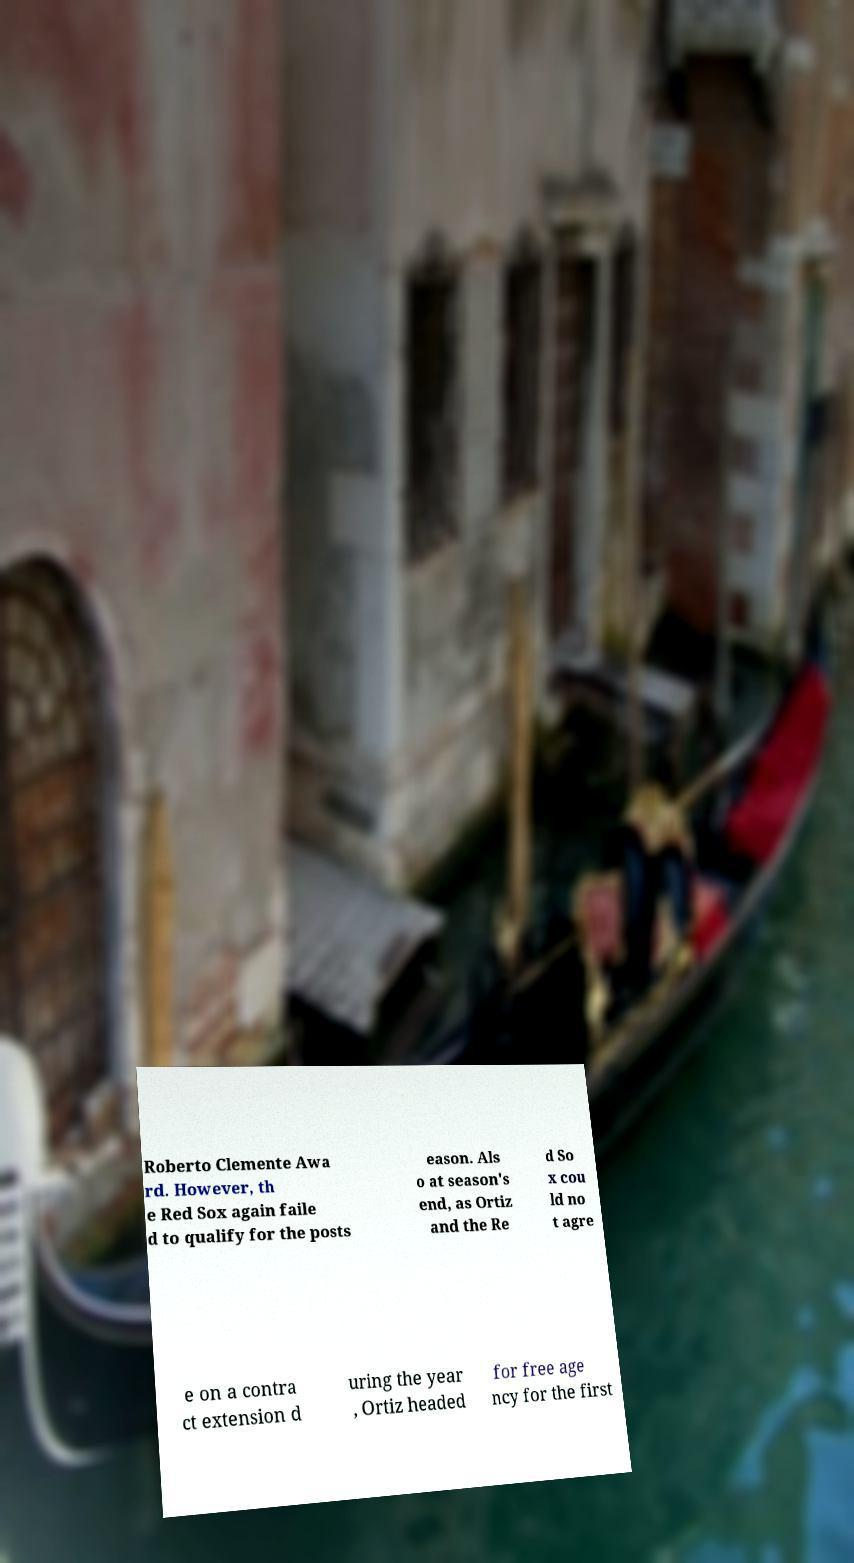What messages or text are displayed in this image? I need them in a readable, typed format. Roberto Clemente Awa rd. However, th e Red Sox again faile d to qualify for the posts eason. Als o at season's end, as Ortiz and the Re d So x cou ld no t agre e on a contra ct extension d uring the year , Ortiz headed for free age ncy for the first 